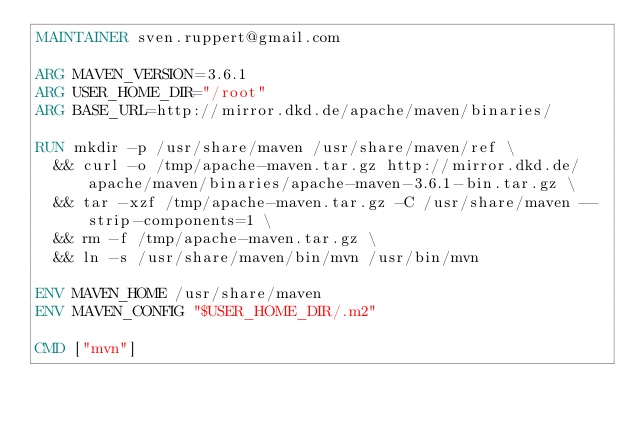Convert code to text. <code><loc_0><loc_0><loc_500><loc_500><_Dockerfile_>MAINTAINER sven.ruppert@gmail.com

ARG MAVEN_VERSION=3.6.1
ARG USER_HOME_DIR="/root"
ARG BASE_URL=http://mirror.dkd.de/apache/maven/binaries/

RUN mkdir -p /usr/share/maven /usr/share/maven/ref \
  && curl -o /tmp/apache-maven.tar.gz http://mirror.dkd.de/apache/maven/binaries/apache-maven-3.6.1-bin.tar.gz \
  && tar -xzf /tmp/apache-maven.tar.gz -C /usr/share/maven --strip-components=1 \
  && rm -f /tmp/apache-maven.tar.gz \
  && ln -s /usr/share/maven/bin/mvn /usr/bin/mvn

ENV MAVEN_HOME /usr/share/maven
ENV MAVEN_CONFIG "$USER_HOME_DIR/.m2"

CMD ["mvn"]</code> 